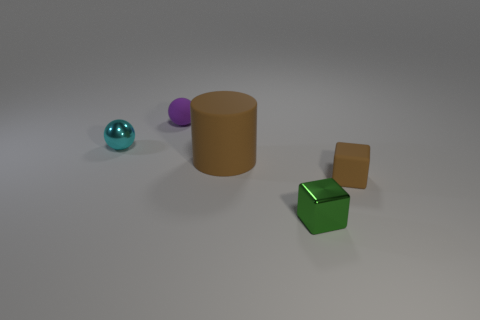Is there anything else that is the same size as the brown rubber cylinder?
Make the answer very short. No. Is there anything else that has the same shape as the big thing?
Your response must be concise. No. What number of spheres are tiny green things or brown rubber things?
Keep it short and to the point. 0. How many other objects are there of the same material as the brown cube?
Your answer should be very brief. 2. There is a brown thing that is behind the matte block; what is its shape?
Ensure brevity in your answer.  Cylinder. What is the big cylinder that is in front of the sphere that is right of the tiny shiny ball made of?
Give a very brief answer. Rubber. Are there more small metallic objects that are in front of the tiny metallic ball than small blue matte things?
Give a very brief answer. Yes. What number of other objects are the same color as the tiny matte block?
Your answer should be compact. 1. There is a cyan metallic thing that is the same size as the green cube; what is its shape?
Your response must be concise. Sphere. There is a metallic thing that is behind the tiny matte object that is in front of the big brown cylinder; how many objects are behind it?
Provide a short and direct response. 1. 